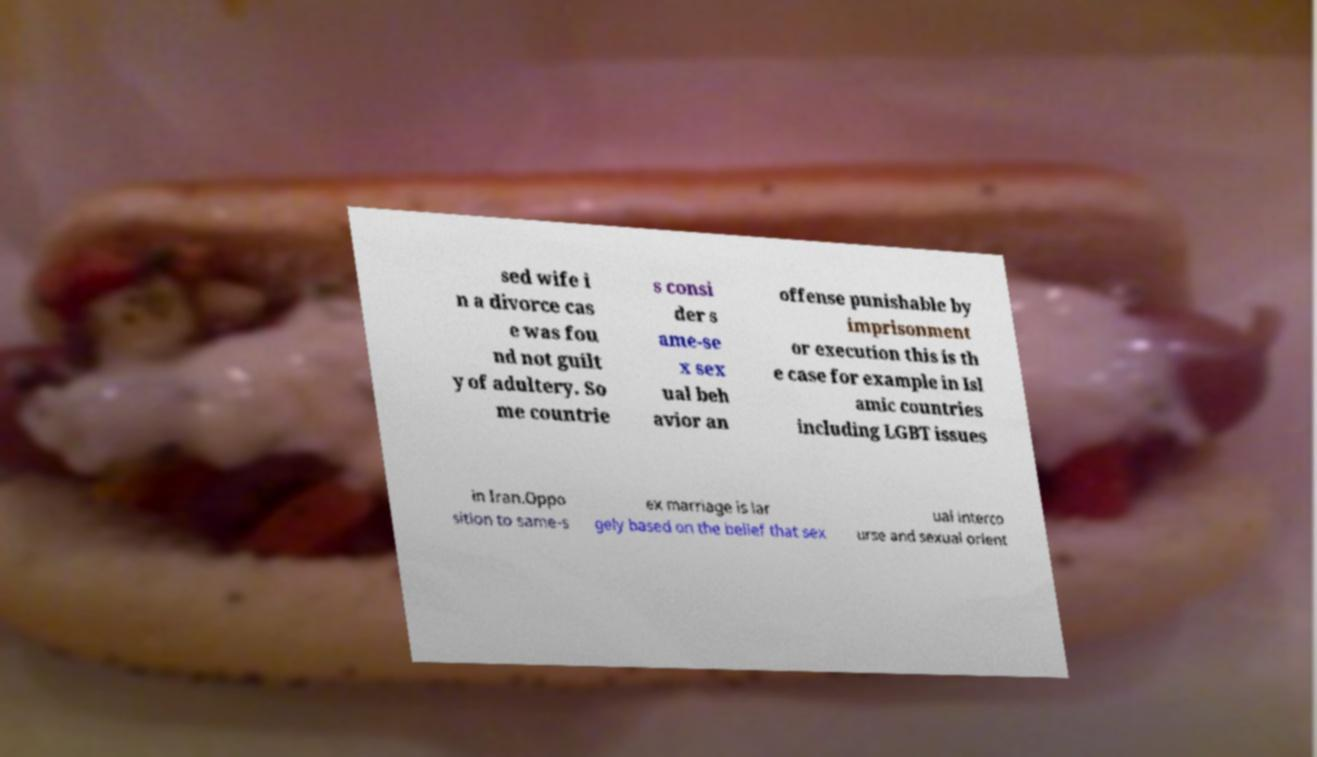Can you read and provide the text displayed in the image?This photo seems to have some interesting text. Can you extract and type it out for me? sed wife i n a divorce cas e was fou nd not guilt y of adultery. So me countrie s consi der s ame-se x sex ual beh avior an offense punishable by imprisonment or execution this is th e case for example in Isl amic countries including LGBT issues in Iran.Oppo sition to same-s ex marriage is lar gely based on the belief that sex ual interco urse and sexual orient 